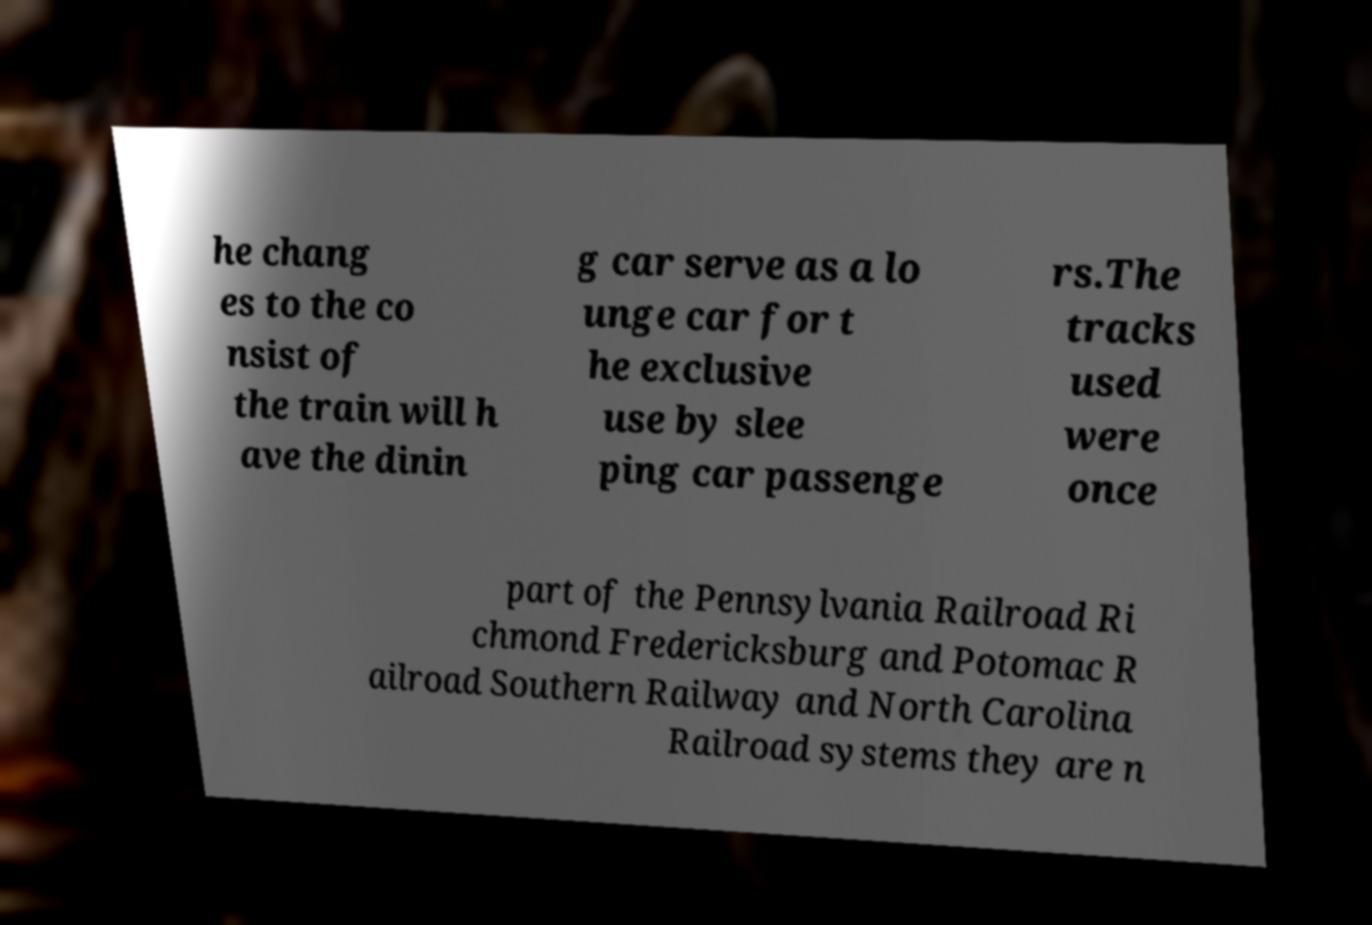Please read and relay the text visible in this image. What does it say? he chang es to the co nsist of the train will h ave the dinin g car serve as a lo unge car for t he exclusive use by slee ping car passenge rs.The tracks used were once part of the Pennsylvania Railroad Ri chmond Fredericksburg and Potomac R ailroad Southern Railway and North Carolina Railroad systems they are n 